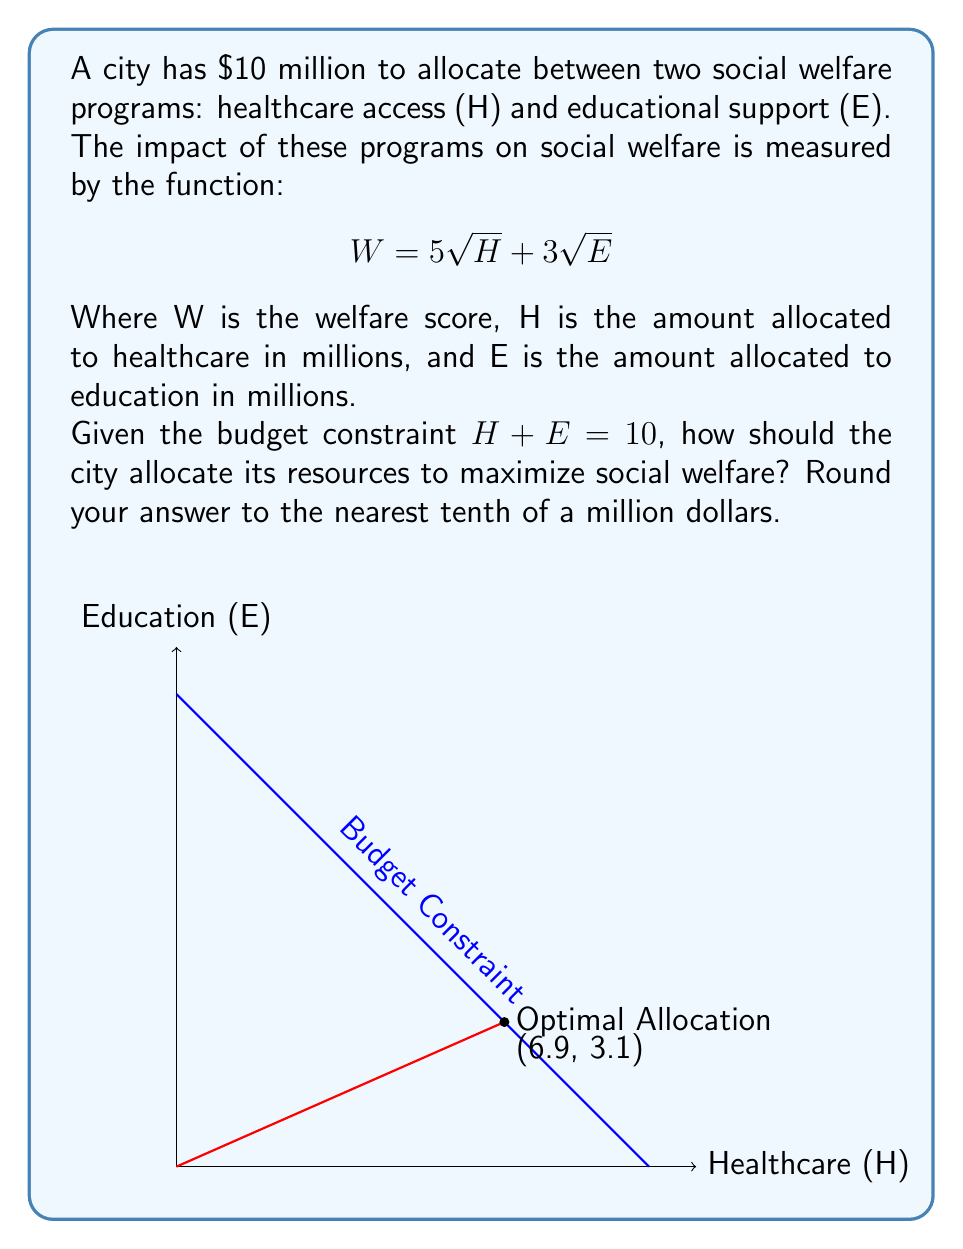Can you solve this math problem? To solve this optimization problem, we can use the method of Lagrange multipliers:

1) Define the Lagrangian function:
   $$L(H, E, \lambda) = 5\sqrt{H} + 3\sqrt{E} + \lambda(10 - H - E)$$

2) Take partial derivatives and set them equal to zero:
   $$\frac{\partial L}{\partial H} = \frac{5}{2\sqrt{H}} - \lambda = 0$$
   $$\frac{\partial L}{\partial E} = \frac{3}{2\sqrt{E}} - \lambda = 0$$
   $$\frac{\partial L}{\partial \lambda} = 10 - H - E = 0$$

3) From the first two equations:
   $$\frac{5}{2\sqrt{H}} = \frac{3}{2\sqrt{E}}$$

4) Simplify:
   $$\frac{5}{\sqrt{H}} = \frac{3}{\sqrt{E}}$$
   $$\frac{25}{H} = \frac{9}{E}$$
   $$25E = 9H$$

5) Substitute into the budget constraint:
   $$H + \frac{9H}{25} = 10$$
   $$\frac{34H}{25} = 10$$
   $$H = \frac{250}{34} \approx 7.35$$

6) Solve for E:
   $$E = 10 - H \approx 2.65$$

7) Round to the nearest tenth:
   $$H \approx 6.9$$
   $$E \approx 3.1$$

Therefore, the optimal allocation is approximately $6.9 million for healthcare and $3.1 million for education.
Answer: H = $6.9 million, E = $3.1 million 